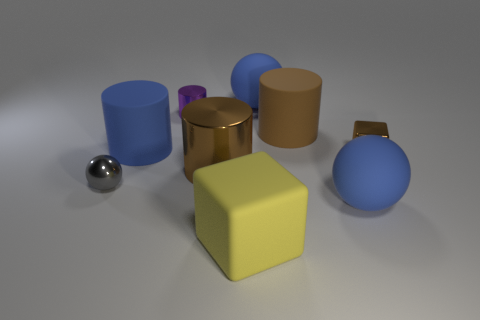Subtract all cylinders. How many objects are left? 5 Subtract all tiny shiny spheres. Subtract all tiny green shiny cubes. How many objects are left? 8 Add 7 tiny purple metallic things. How many tiny purple metallic things are left? 8 Add 6 small purple cylinders. How many small purple cylinders exist? 7 Subtract 0 gray cylinders. How many objects are left? 9 